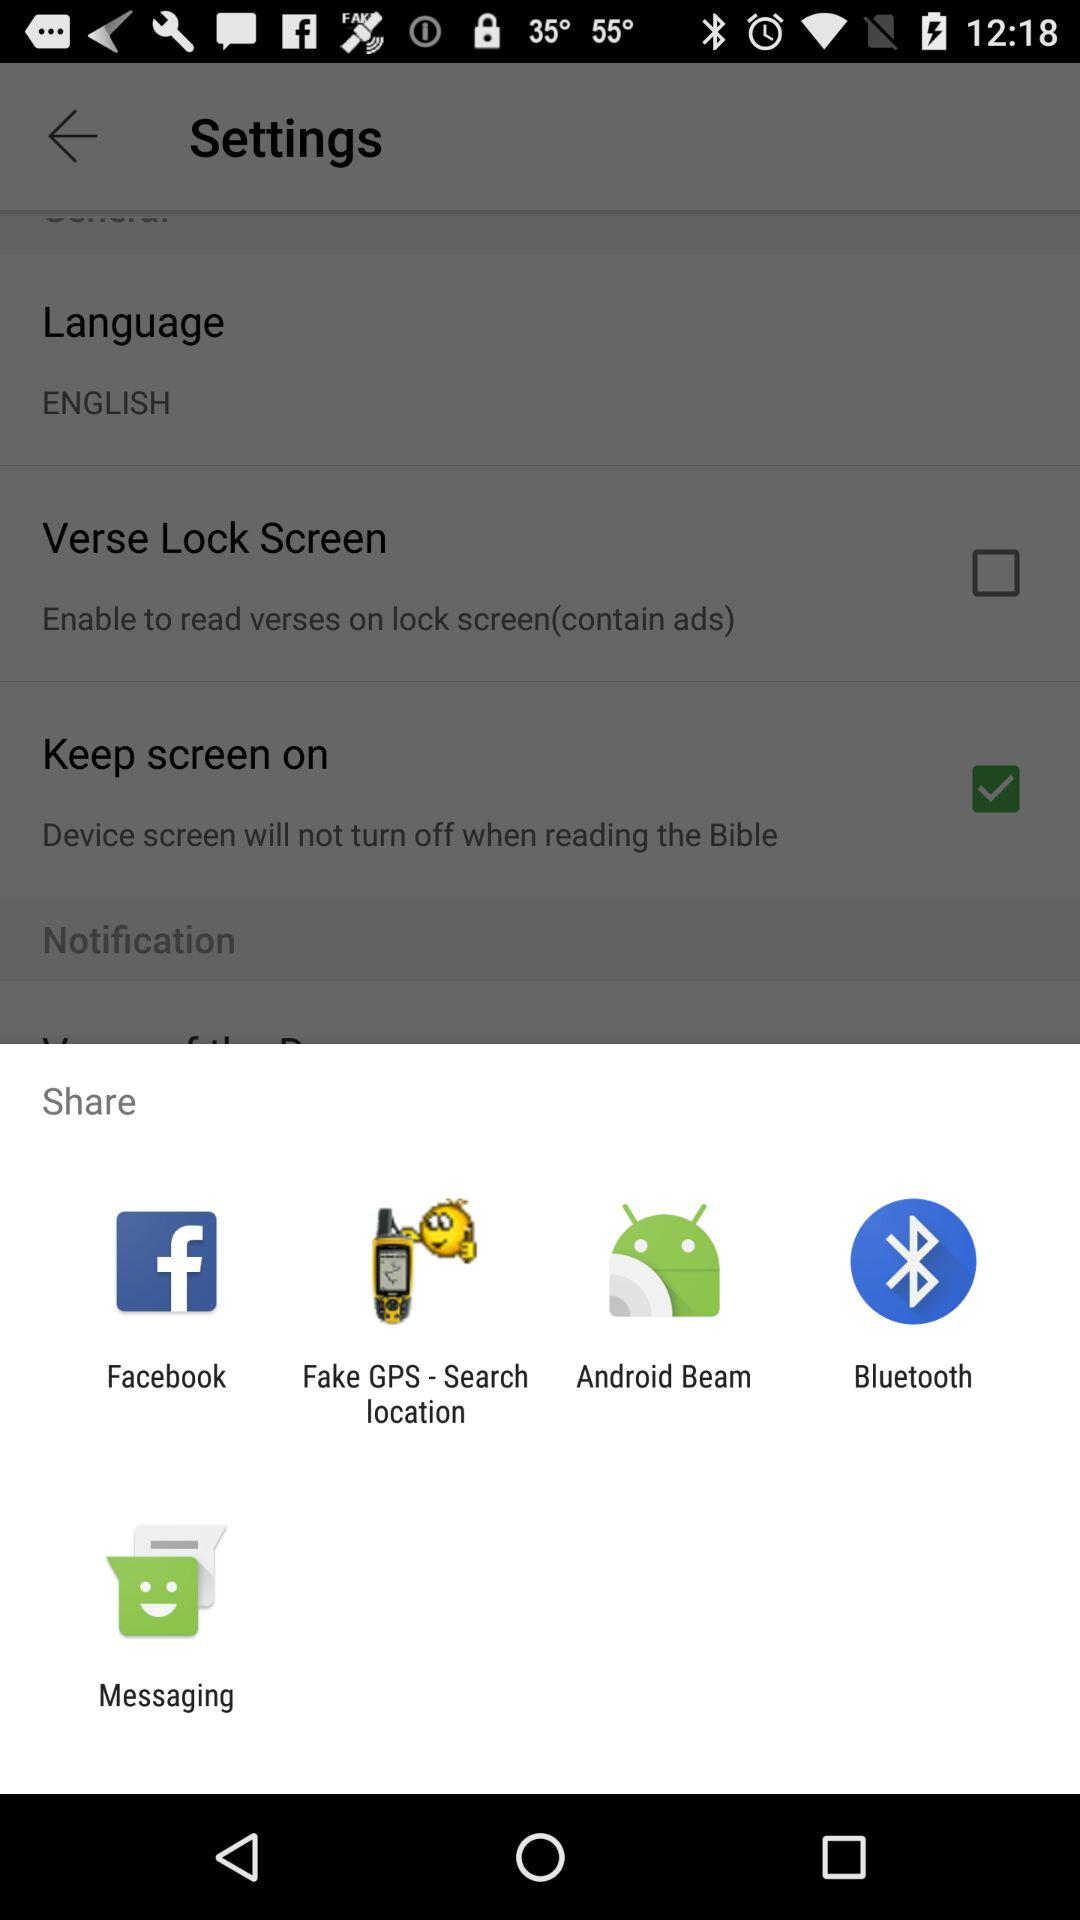What are the options to share? The options are "Facebook", "Fake GPS - Search location", "Android Beam", "Bluetooth" and "Messaging". 